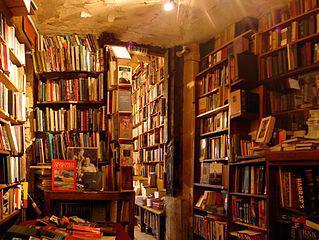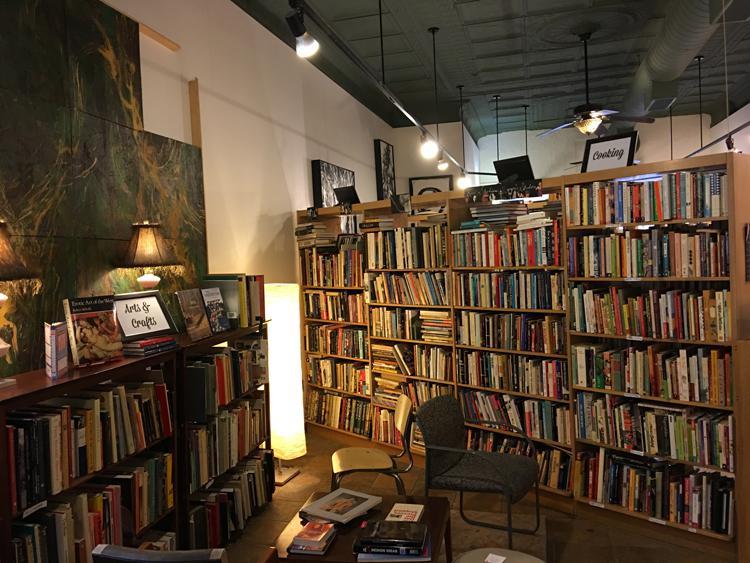The first image is the image on the left, the second image is the image on the right. Considering the images on both sides, is "Ceiling lights are visible in both images." valid? Answer yes or no. Yes. The first image is the image on the left, the second image is the image on the right. Given the left and right images, does the statement "Seats are available in the reading area in the image on the right." hold true? Answer yes or no. Yes. 